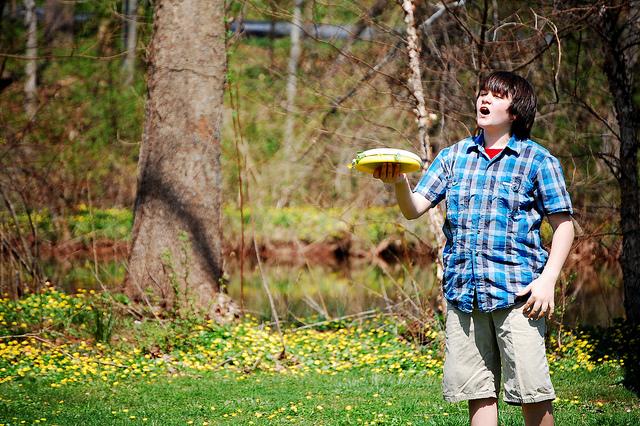What color is the boy's shirt?
Keep it brief. Blue. Is it spring or Autumn?
Give a very brief answer. Spring. What is the boy holding?
Write a very short answer. Frisbee. 